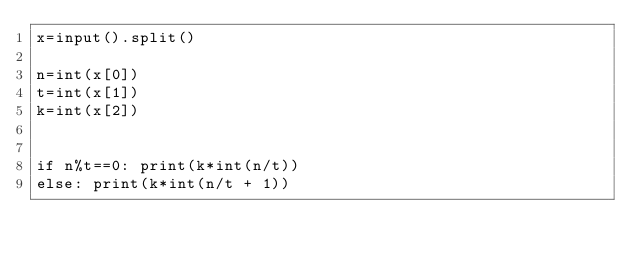Convert code to text. <code><loc_0><loc_0><loc_500><loc_500><_Python_>x=input().split()

n=int(x[0])
t=int(x[1])
k=int(x[2])


if n%t==0: print(k*int(n/t))
else: print(k*int(n/t + 1))




</code> 